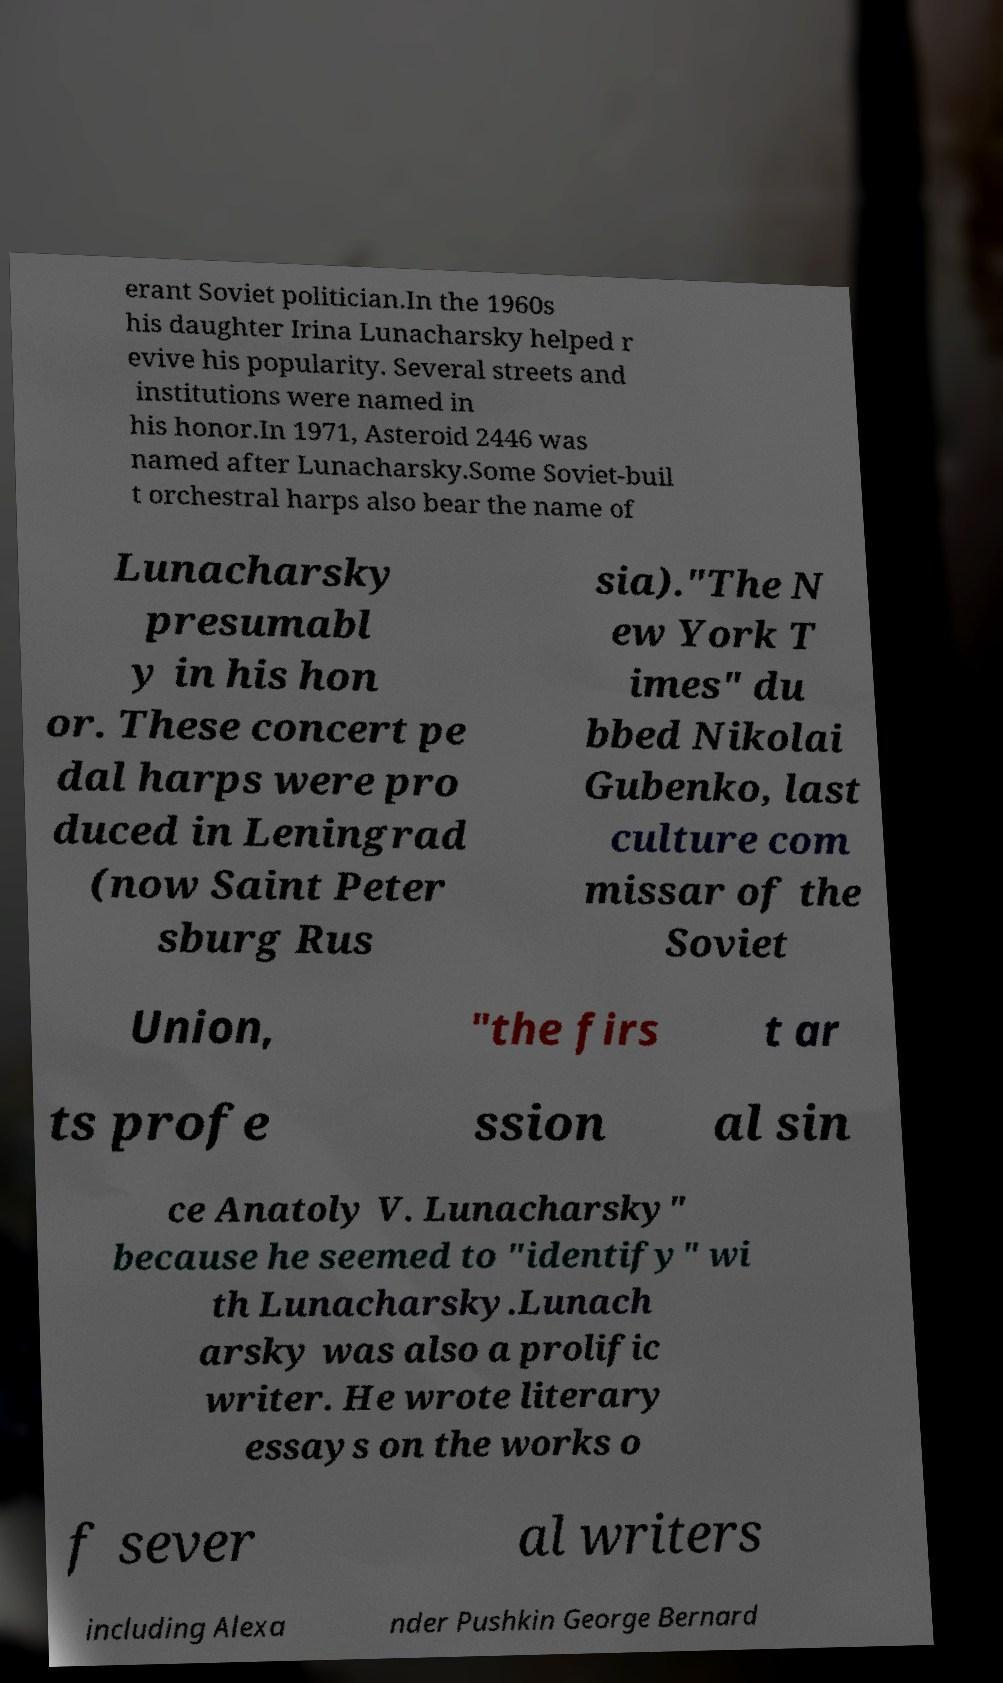Please identify and transcribe the text found in this image. erant Soviet politician.In the 1960s his daughter Irina Lunacharsky helped r evive his popularity. Several streets and institutions were named in his honor.In 1971, Asteroid 2446 was named after Lunacharsky.Some Soviet-buil t orchestral harps also bear the name of Lunacharsky presumabl y in his hon or. These concert pe dal harps were pro duced in Leningrad (now Saint Peter sburg Rus sia)."The N ew York T imes" du bbed Nikolai Gubenko, last culture com missar of the Soviet Union, "the firs t ar ts profe ssion al sin ce Anatoly V. Lunacharsky" because he seemed to "identify" wi th Lunacharsky.Lunach arsky was also a prolific writer. He wrote literary essays on the works o f sever al writers including Alexa nder Pushkin George Bernard 